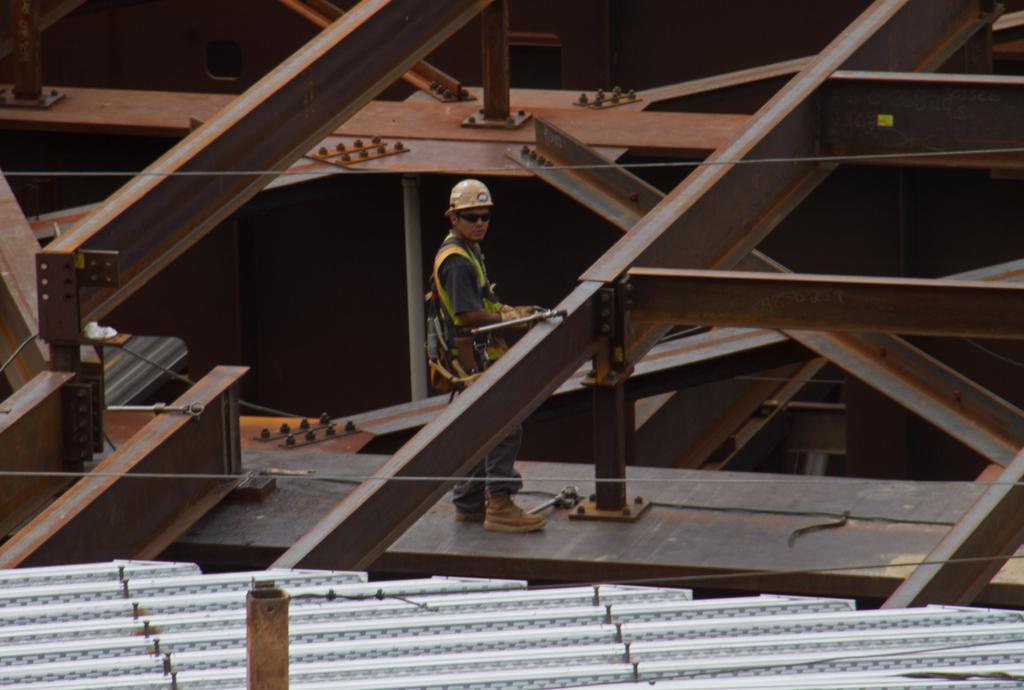Could you give a brief overview of what you see in this image? In this image we can see there is a person standing on the iron rod. And there is a shed. 